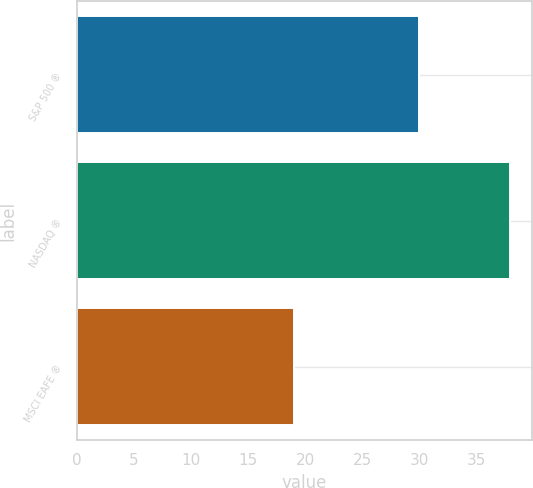<chart> <loc_0><loc_0><loc_500><loc_500><bar_chart><fcel>S&P 500 ®<fcel>NASDAQ ®<fcel>MSCI EAFE ®<nl><fcel>30<fcel>38<fcel>19<nl></chart> 